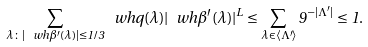Convert formula to latex. <formula><loc_0><loc_0><loc_500><loc_500>\sum _ { \lambda \colon | \ w h { \beta ^ { \prime } } ( \lambda ) | \leq 1 / 3 } { \ w h { q } ( \lambda ) | \ w h { \beta ^ { \prime } } ( \lambda ) | ^ { L } } \leq \sum _ { \lambda \in \langle \Lambda ^ { \prime } \rangle } { 9 ^ { - | \Lambda ^ { \prime } | } } \leq 1 .</formula> 